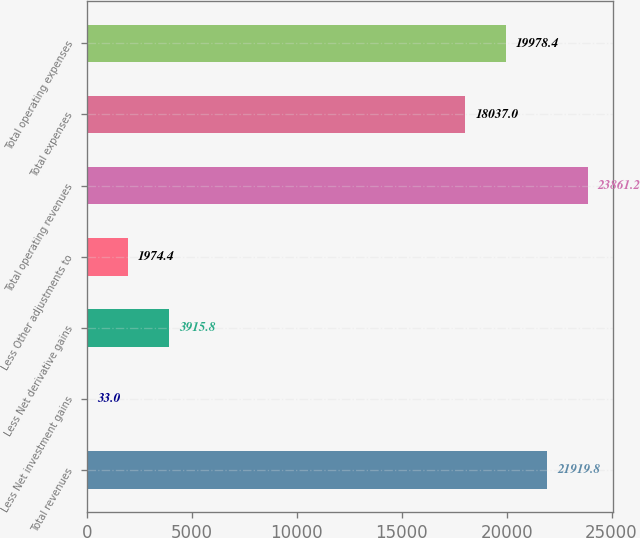Convert chart. <chart><loc_0><loc_0><loc_500><loc_500><bar_chart><fcel>Total revenues<fcel>Less Net investment gains<fcel>Less Net derivative gains<fcel>Less Other adjustments to<fcel>Total operating revenues<fcel>Total expenses<fcel>Total operating expenses<nl><fcel>21919.8<fcel>33<fcel>3915.8<fcel>1974.4<fcel>23861.2<fcel>18037<fcel>19978.4<nl></chart> 